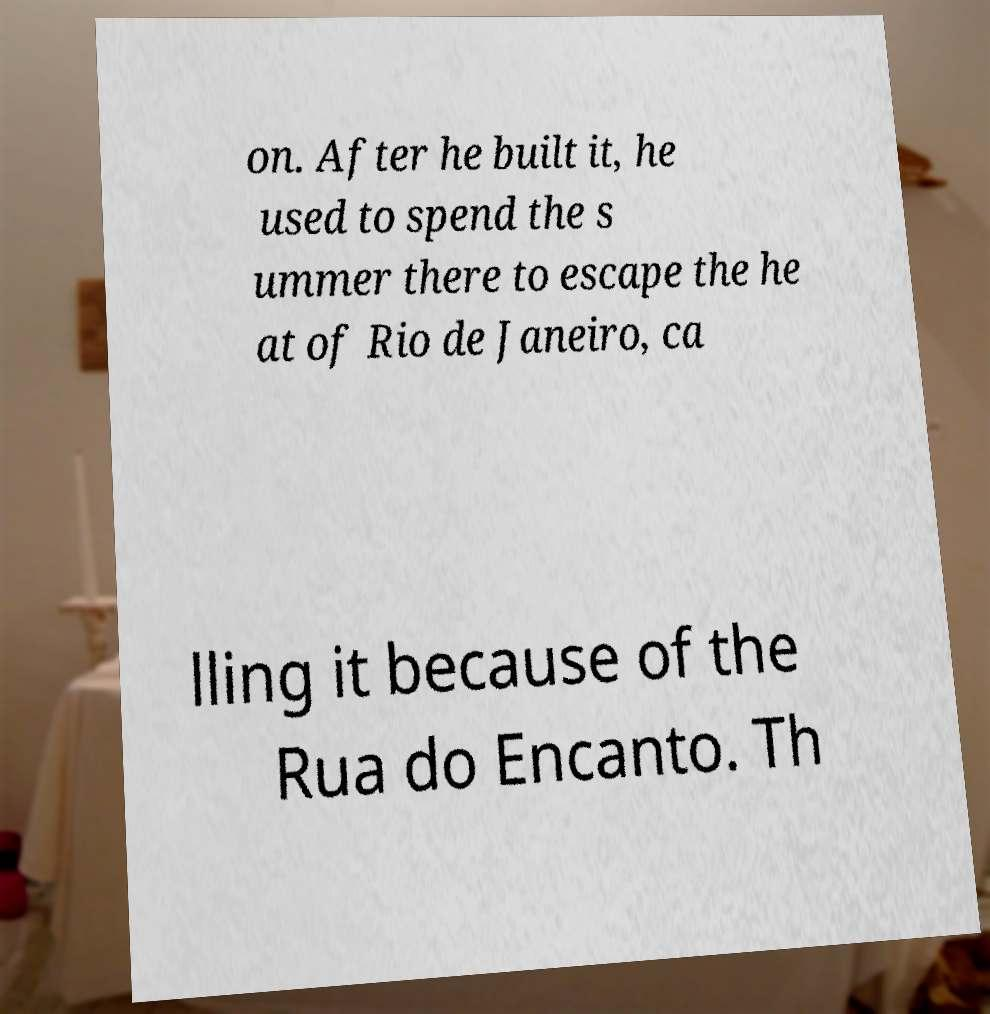What messages or text are displayed in this image? I need them in a readable, typed format. on. After he built it, he used to spend the s ummer there to escape the he at of Rio de Janeiro, ca lling it because of the Rua do Encanto. Th 